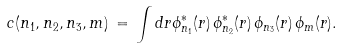Convert formula to latex. <formula><loc_0><loc_0><loc_500><loc_500>c ( n _ { 1 } , n _ { 2 } , n _ { 3 } , m ) \, = \, \int d r \phi _ { n _ { 1 } } ^ { * } ( r ) \, \phi _ { n _ { 2 } } ^ { * } ( r ) \, \phi _ { n _ { 3 } } ( r ) \, \phi _ { m } ( r ) .</formula> 